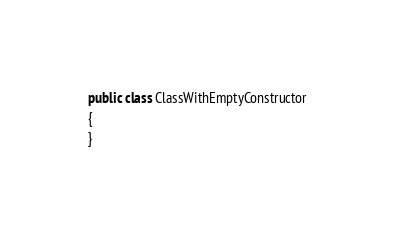<code> <loc_0><loc_0><loc_500><loc_500><_C#_>public class ClassWithEmptyConstructor
{
}</code> 